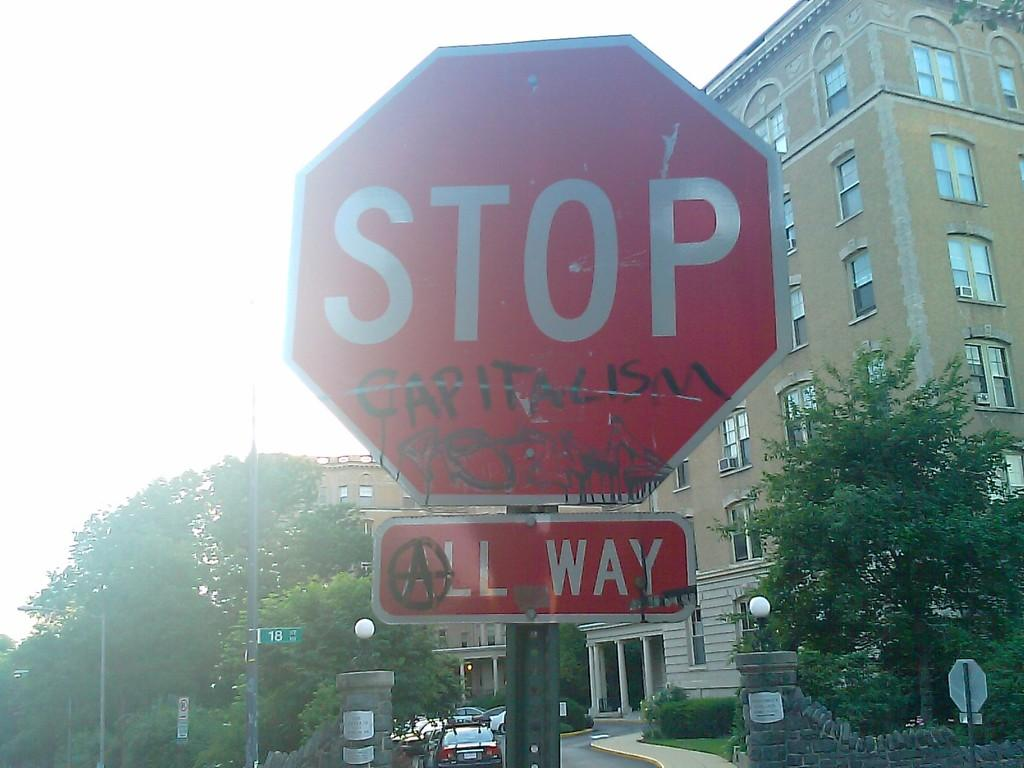<image>
Create a compact narrative representing the image presented. An All Way Stop sign is graffitted with the word Capitalism.. 